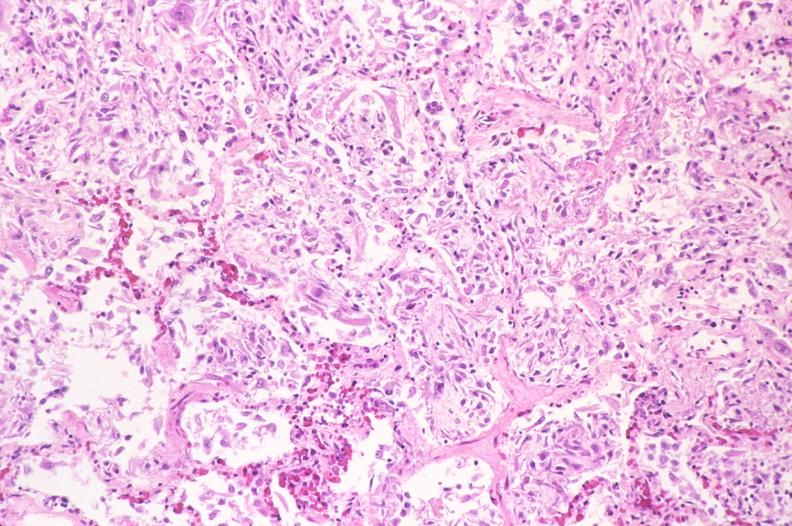what is present?
Answer the question using a single word or phrase. Respiratory 